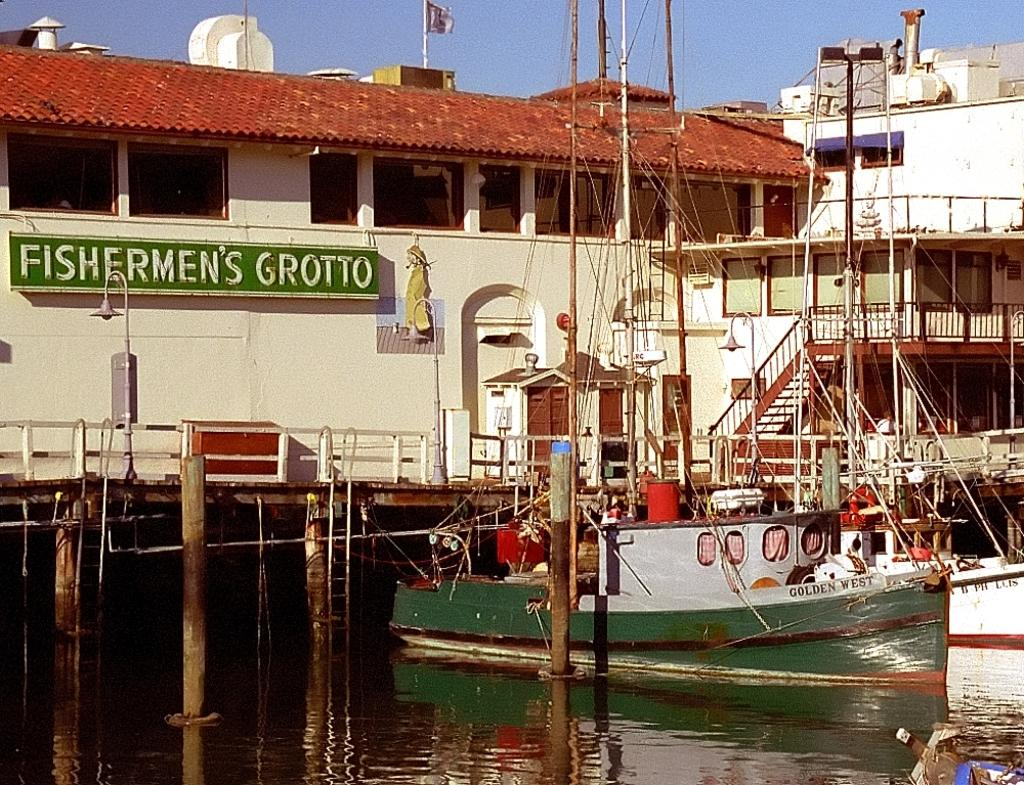<image>
Relay a brief, clear account of the picture shown. A sailboat sits in the water next to Fishermen's Grotto. 